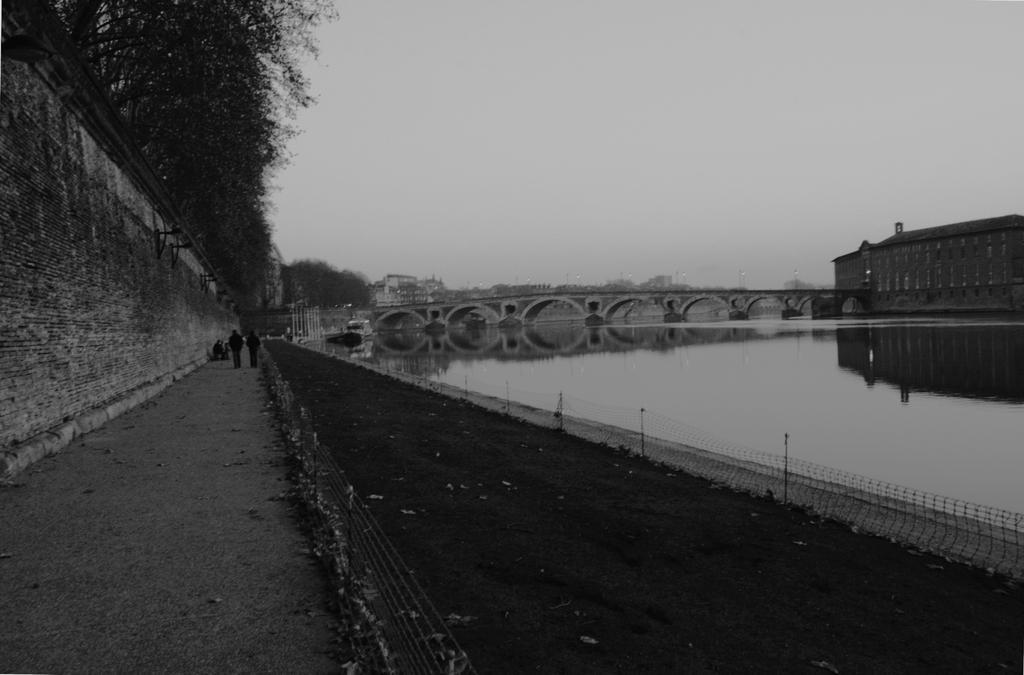Describe this image in one or two sentences. In this image we can see a bridge. In front of the bridge we can see the water and fencing. On the left side, we can see persons, trees and a wall. On the right side, we can see a building and we can see the reflection of building on the water. At the top we can see the sky. 